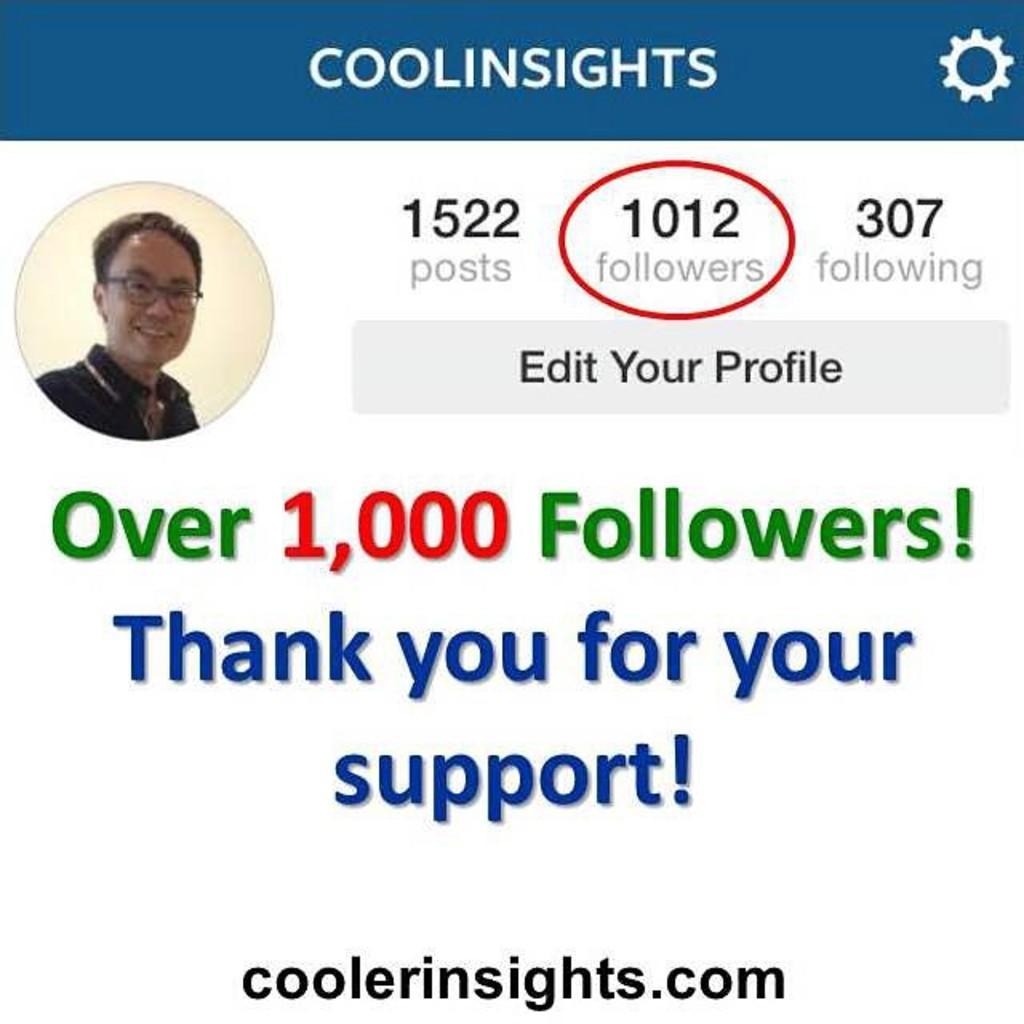Please provide a concise description of this image. In the image there is a page. To the top of the image there is a blue bar with a name and settings symbol on it. Below that to the left side there is a profile of a man. And to the right side there are posts, follower and following numbers. Below that there is a bar with edit your profile on it. In the middle of the image there is a message. And to the bottom of the image there is a website address. 